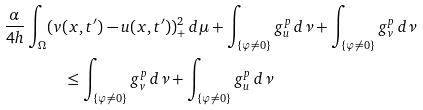<formula> <loc_0><loc_0><loc_500><loc_500>\frac { \alpha } { 4 h } \int _ { \Omega } & ( v ( x , t ^ { \prime } ) - u ( x , t ^ { \prime } ) ) _ { + } ^ { 2 } \, d \mu + \int _ { \{ \varphi \neq 0 \} } g _ { u } ^ { p } \, d \nu + \int _ { \{ \varphi \neq 0 \} } g _ { v } ^ { p } \, d \nu \\ & \quad \leq \int _ { \{ \varphi \neq 0 \} } g _ { v } ^ { p } \, d \nu + \int _ { \{ \varphi \neq 0 \} } g _ { u } ^ { p } \, d \nu</formula> 